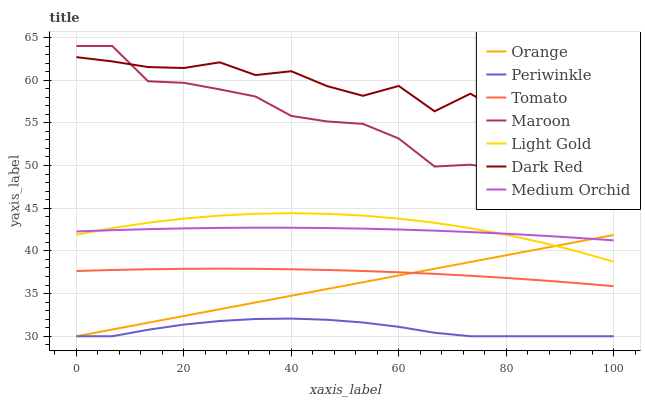Does Periwinkle have the minimum area under the curve?
Answer yes or no. Yes. Does Dark Red have the maximum area under the curve?
Answer yes or no. Yes. Does Medium Orchid have the minimum area under the curve?
Answer yes or no. No. Does Medium Orchid have the maximum area under the curve?
Answer yes or no. No. Is Orange the smoothest?
Answer yes or no. Yes. Is Dark Red the roughest?
Answer yes or no. Yes. Is Medium Orchid the smoothest?
Answer yes or no. No. Is Medium Orchid the roughest?
Answer yes or no. No. Does Periwinkle have the lowest value?
Answer yes or no. Yes. Does Medium Orchid have the lowest value?
Answer yes or no. No. Does Maroon have the highest value?
Answer yes or no. Yes. Does Dark Red have the highest value?
Answer yes or no. No. Is Periwinkle less than Maroon?
Answer yes or no. Yes. Is Medium Orchid greater than Periwinkle?
Answer yes or no. Yes. Does Tomato intersect Orange?
Answer yes or no. Yes. Is Tomato less than Orange?
Answer yes or no. No. Is Tomato greater than Orange?
Answer yes or no. No. Does Periwinkle intersect Maroon?
Answer yes or no. No. 